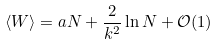<formula> <loc_0><loc_0><loc_500><loc_500>\langle W \rangle = a N + \frac { 2 } { k ^ { 2 } } \ln N + \mathcal { O } ( 1 )</formula> 